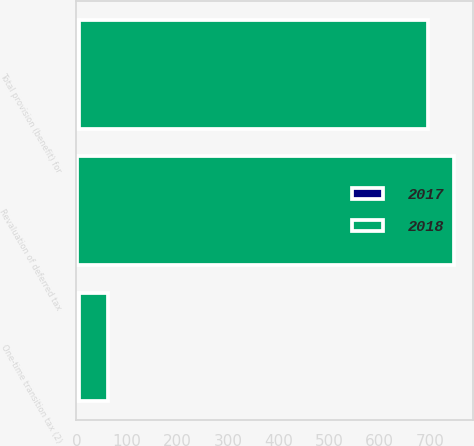<chart> <loc_0><loc_0><loc_500><loc_500><stacked_bar_chart><ecel><fcel>Revaluation of deferred tax<fcel>One-time transition tax (2)<fcel>Total provision (benefit) for<nl><fcel>2017<fcel>1<fcel>5<fcel>6<nl><fcel>2018<fcel>746<fcel>57<fcel>689<nl></chart> 